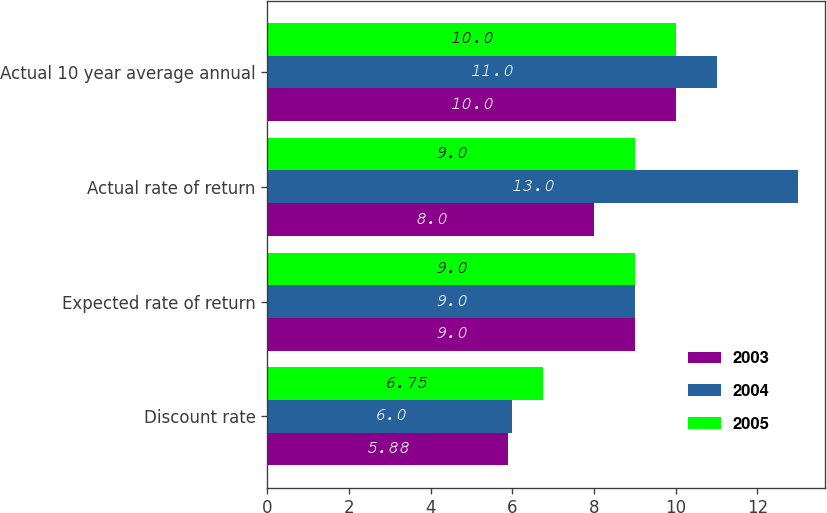Convert chart. <chart><loc_0><loc_0><loc_500><loc_500><stacked_bar_chart><ecel><fcel>Discount rate<fcel>Expected rate of return<fcel>Actual rate of return<fcel>Actual 10 year average annual<nl><fcel>2003<fcel>5.88<fcel>9<fcel>8<fcel>10<nl><fcel>2004<fcel>6<fcel>9<fcel>13<fcel>11<nl><fcel>2005<fcel>6.75<fcel>9<fcel>9<fcel>10<nl></chart> 